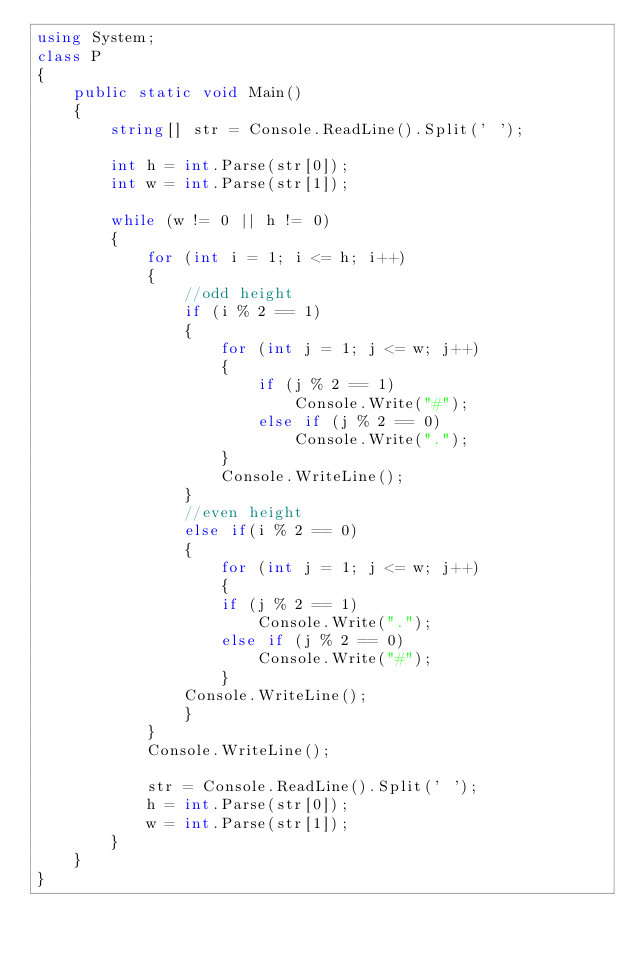Convert code to text. <code><loc_0><loc_0><loc_500><loc_500><_C#_>using System;
class P
{
    public static void Main()
    {
        string[] str = Console.ReadLine().Split(' ');

        int h = int.Parse(str[0]);
        int w = int.Parse(str[1]);

        while (w != 0 || h != 0)
        {
            for (int i = 1; i <= h; i++)
            {
                //odd height
                if (i % 2 == 1)
                {
                    for (int j = 1; j <= w; j++)
                    {
                        if (j % 2 == 1)
                            Console.Write("#");
                        else if (j % 2 == 0)
                            Console.Write(".");
                    }
                    Console.WriteLine();
                }
                //even height
                else if(i % 2 == 0)
                {
                    for (int j = 1; j <= w; j++)
                    {
                    if (j % 2 == 1)
                        Console.Write(".");
                    else if (j % 2 == 0)
                        Console.Write("#");
                    }
                Console.WriteLine();
                }                        
            }
            Console.WriteLine();

            str = Console.ReadLine().Split(' ');
            h = int.Parse(str[0]);
            w = int.Parse(str[1]);
        }
    }
}
</code> 